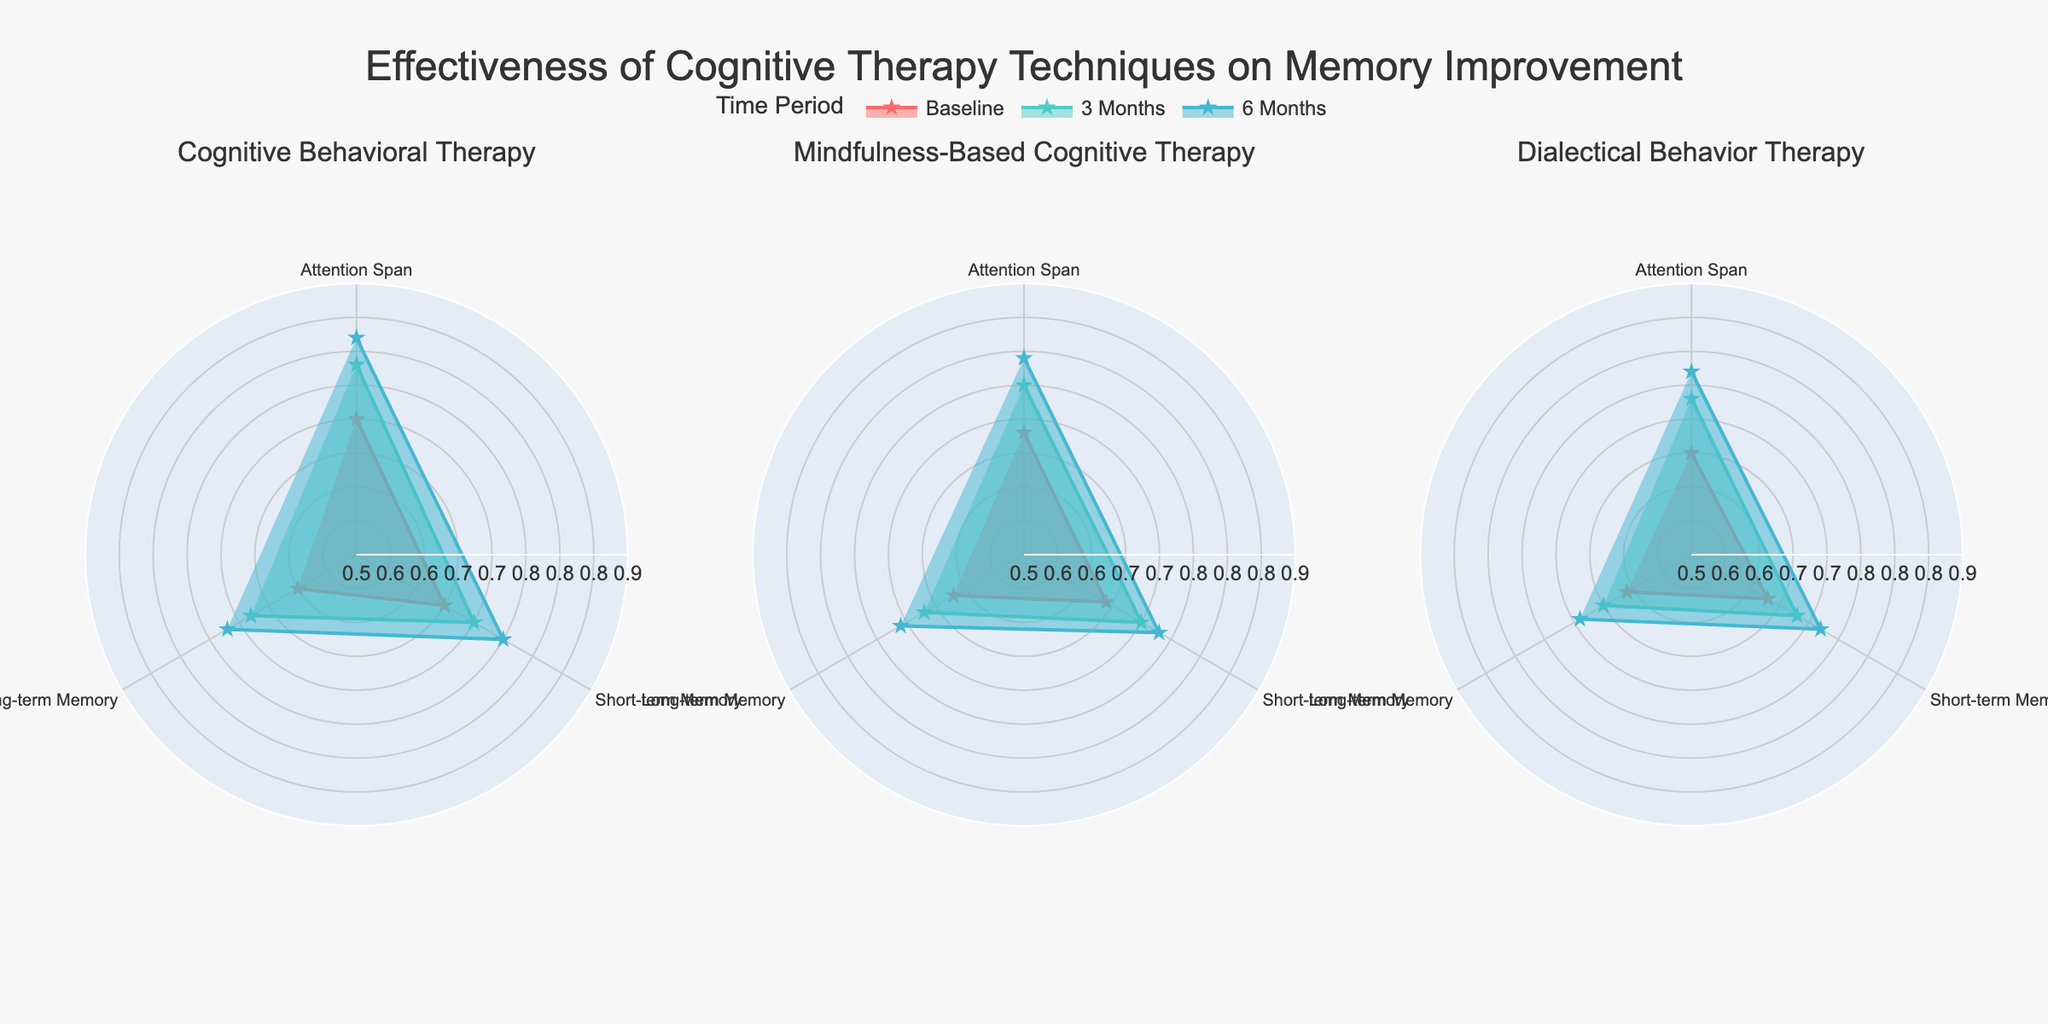What is the title of the figure? The title of the figure is usually found at the top and is clearly stated to give an overview of what the chart represents. In this case, it reads "Effectiveness of Cognitive Therapy Techniques on Memory Improvement."
Answer: Effectiveness of Cognitive Therapy Techniques on Memory Improvement What are the techniques compared in the polar charts? Each subplot represents a different cognitive therapy technique, with their names given in the subplot titles. The techniques compared are Cognitive Behavioral Therapy, Mindfulness-Based Cognitive Therapy, and Dialectical Behavior Therapy.
Answer: Cognitive Behavioral Therapy, Mindfulness-Based Cognitive Therapy, Dialectical Behavior Therapy Which cognitive therapy technique shows the highest improvement in attention span after 6 months? To find this, look at the outermost point (corresponding to 6 months) closest to the edge of the polar chart in the "Attention Span" domain for each therapy. Mindfulness-Based Cognitive Therapy shows the highest value at 0.79.
Answer: Mindfulness-Based Cognitive Therapy How does the baseline long-term memory performance compare between the three techniques? Look at the point closest to the center in the "Long-term Memory" domain for each therapy at the baseline. Cognitive Behavioral Therapy (0.6), Mindfulness-Based Cognitive Therapy (0.62), and Dialectical Behavior Therapy (0.61).
Answer: 0.6, 0.62, 0.61 Which technique shows the most consistent improvement across all domains and time periods? To determine consistency of improvement, look at how steadily the values increase in each domain over time. Cognitive Behavioral Therapy shows consistent improvement in all three domains without any significant drops.
Answer: Cognitive Behavioral Therapy What is the difference in short-term memory improvement at 3 months between Cognitive Behavioral Therapy and Dialectical Behavior Therapy? Locate the 3-month value in the "Short-term Memory" domain for both therapies. Cognitive Behavioral Therapy shows 0.7 and Dialectical Behavior Therapy shows 0.68. The difference is 0.02.
Answer: 0.02 What is the average improvement in long-term memory for Mindfulness-Based Cognitive Therapy over 6 months? Average improvement can be calculated by taking the values at each time point and finding their mean. For Mindfulness-Based Cognitive Therapy: (0.62 + 0.67 + 0.71) / 3 = 2.0 / 3 = 0.67.
Answer: 0.67 Which time period shows the highest overall improvements across all techniques and domains? Examine the outermost ring (6 Months) across all techniques and domains to see the highest collective improvement. Most values are highest at 6 Months.
Answer: 6 Months Which domain shows the least improvement over time for Dialectical Behavior Therapy? Look at the change in values from baseline to 6 months for each domain. Long-term Memory shows the least improvement from 0.61 to 0.69.
Answer: Long-term Memory 